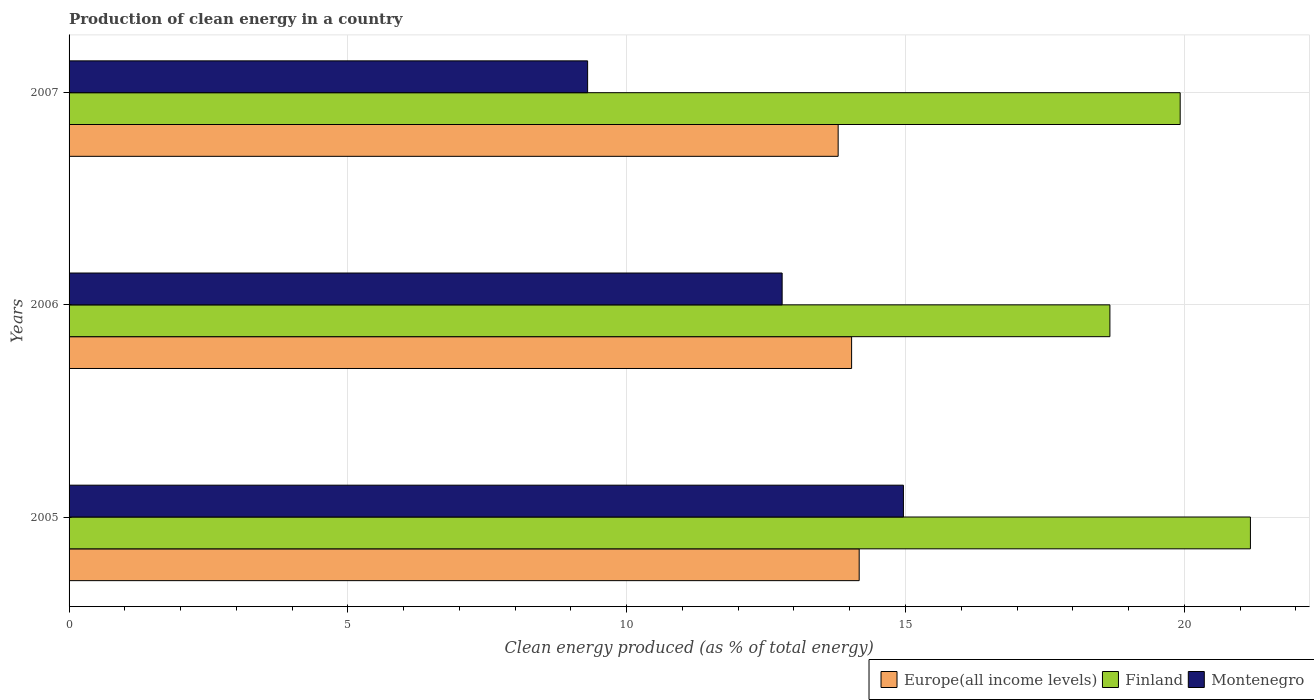How many groups of bars are there?
Offer a terse response. 3. How many bars are there on the 1st tick from the top?
Offer a very short reply. 3. What is the label of the 2nd group of bars from the top?
Your response must be concise. 2006. What is the percentage of clean energy produced in Montenegro in 2007?
Your answer should be very brief. 9.3. Across all years, what is the maximum percentage of clean energy produced in Montenegro?
Ensure brevity in your answer.  14.96. Across all years, what is the minimum percentage of clean energy produced in Montenegro?
Offer a very short reply. 9.3. In which year was the percentage of clean energy produced in Finland maximum?
Your response must be concise. 2005. What is the total percentage of clean energy produced in Montenegro in the graph?
Provide a succinct answer. 37.05. What is the difference between the percentage of clean energy produced in Europe(all income levels) in 2006 and that in 2007?
Offer a very short reply. 0.24. What is the difference between the percentage of clean energy produced in Montenegro in 2005 and the percentage of clean energy produced in Finland in 2007?
Offer a terse response. -4.96. What is the average percentage of clean energy produced in Europe(all income levels) per year?
Your response must be concise. 14. In the year 2006, what is the difference between the percentage of clean energy produced in Montenegro and percentage of clean energy produced in Europe(all income levels)?
Make the answer very short. -1.25. In how many years, is the percentage of clean energy produced in Finland greater than 6 %?
Keep it short and to the point. 3. What is the ratio of the percentage of clean energy produced in Europe(all income levels) in 2005 to that in 2007?
Provide a succinct answer. 1.03. Is the percentage of clean energy produced in Finland in 2005 less than that in 2006?
Provide a short and direct response. No. What is the difference between the highest and the second highest percentage of clean energy produced in Europe(all income levels)?
Make the answer very short. 0.14. What is the difference between the highest and the lowest percentage of clean energy produced in Finland?
Provide a succinct answer. 2.52. In how many years, is the percentage of clean energy produced in Finland greater than the average percentage of clean energy produced in Finland taken over all years?
Your response must be concise. 2. What does the 3rd bar from the top in 2007 represents?
Provide a short and direct response. Europe(all income levels). Is it the case that in every year, the sum of the percentage of clean energy produced in Europe(all income levels) and percentage of clean energy produced in Finland is greater than the percentage of clean energy produced in Montenegro?
Give a very brief answer. Yes. How many bars are there?
Your answer should be compact. 9. Are all the bars in the graph horizontal?
Offer a terse response. Yes. Are the values on the major ticks of X-axis written in scientific E-notation?
Your answer should be compact. No. Does the graph contain any zero values?
Give a very brief answer. No. Does the graph contain grids?
Offer a very short reply. Yes. What is the title of the graph?
Give a very brief answer. Production of clean energy in a country. What is the label or title of the X-axis?
Provide a succinct answer. Clean energy produced (as % of total energy). What is the label or title of the Y-axis?
Your answer should be compact. Years. What is the Clean energy produced (as % of total energy) of Europe(all income levels) in 2005?
Keep it short and to the point. 14.17. What is the Clean energy produced (as % of total energy) in Finland in 2005?
Your answer should be very brief. 21.19. What is the Clean energy produced (as % of total energy) in Montenegro in 2005?
Provide a succinct answer. 14.96. What is the Clean energy produced (as % of total energy) in Europe(all income levels) in 2006?
Your answer should be compact. 14.03. What is the Clean energy produced (as % of total energy) in Finland in 2006?
Ensure brevity in your answer.  18.67. What is the Clean energy produced (as % of total energy) of Montenegro in 2006?
Your answer should be very brief. 12.79. What is the Clean energy produced (as % of total energy) in Europe(all income levels) in 2007?
Offer a terse response. 13.79. What is the Clean energy produced (as % of total energy) of Finland in 2007?
Offer a very short reply. 19.93. What is the Clean energy produced (as % of total energy) of Montenegro in 2007?
Provide a short and direct response. 9.3. Across all years, what is the maximum Clean energy produced (as % of total energy) of Europe(all income levels)?
Provide a succinct answer. 14.17. Across all years, what is the maximum Clean energy produced (as % of total energy) in Finland?
Give a very brief answer. 21.19. Across all years, what is the maximum Clean energy produced (as % of total energy) of Montenegro?
Your response must be concise. 14.96. Across all years, what is the minimum Clean energy produced (as % of total energy) of Europe(all income levels)?
Your answer should be very brief. 13.79. Across all years, what is the minimum Clean energy produced (as % of total energy) of Finland?
Provide a succinct answer. 18.67. Across all years, what is the minimum Clean energy produced (as % of total energy) of Montenegro?
Offer a very short reply. 9.3. What is the total Clean energy produced (as % of total energy) of Europe(all income levels) in the graph?
Give a very brief answer. 42. What is the total Clean energy produced (as % of total energy) of Finland in the graph?
Provide a succinct answer. 59.78. What is the total Clean energy produced (as % of total energy) of Montenegro in the graph?
Make the answer very short. 37.05. What is the difference between the Clean energy produced (as % of total energy) of Europe(all income levels) in 2005 and that in 2006?
Provide a short and direct response. 0.14. What is the difference between the Clean energy produced (as % of total energy) in Finland in 2005 and that in 2006?
Your answer should be very brief. 2.52. What is the difference between the Clean energy produced (as % of total energy) of Montenegro in 2005 and that in 2006?
Offer a very short reply. 2.17. What is the difference between the Clean energy produced (as % of total energy) of Europe(all income levels) in 2005 and that in 2007?
Your answer should be very brief. 0.38. What is the difference between the Clean energy produced (as % of total energy) in Finland in 2005 and that in 2007?
Give a very brief answer. 1.26. What is the difference between the Clean energy produced (as % of total energy) in Montenegro in 2005 and that in 2007?
Your answer should be very brief. 5.66. What is the difference between the Clean energy produced (as % of total energy) of Europe(all income levels) in 2006 and that in 2007?
Offer a very short reply. 0.24. What is the difference between the Clean energy produced (as % of total energy) of Finland in 2006 and that in 2007?
Ensure brevity in your answer.  -1.26. What is the difference between the Clean energy produced (as % of total energy) of Montenegro in 2006 and that in 2007?
Your answer should be very brief. 3.49. What is the difference between the Clean energy produced (as % of total energy) of Europe(all income levels) in 2005 and the Clean energy produced (as % of total energy) of Finland in 2006?
Provide a short and direct response. -4.5. What is the difference between the Clean energy produced (as % of total energy) in Europe(all income levels) in 2005 and the Clean energy produced (as % of total energy) in Montenegro in 2006?
Offer a very short reply. 1.38. What is the difference between the Clean energy produced (as % of total energy) of Finland in 2005 and the Clean energy produced (as % of total energy) of Montenegro in 2006?
Provide a succinct answer. 8.4. What is the difference between the Clean energy produced (as % of total energy) of Europe(all income levels) in 2005 and the Clean energy produced (as % of total energy) of Finland in 2007?
Your response must be concise. -5.76. What is the difference between the Clean energy produced (as % of total energy) in Europe(all income levels) in 2005 and the Clean energy produced (as % of total energy) in Montenegro in 2007?
Offer a terse response. 4.87. What is the difference between the Clean energy produced (as % of total energy) of Finland in 2005 and the Clean energy produced (as % of total energy) of Montenegro in 2007?
Make the answer very short. 11.89. What is the difference between the Clean energy produced (as % of total energy) in Europe(all income levels) in 2006 and the Clean energy produced (as % of total energy) in Finland in 2007?
Offer a terse response. -5.89. What is the difference between the Clean energy produced (as % of total energy) in Europe(all income levels) in 2006 and the Clean energy produced (as % of total energy) in Montenegro in 2007?
Ensure brevity in your answer.  4.73. What is the difference between the Clean energy produced (as % of total energy) of Finland in 2006 and the Clean energy produced (as % of total energy) of Montenegro in 2007?
Give a very brief answer. 9.37. What is the average Clean energy produced (as % of total energy) in Europe(all income levels) per year?
Your response must be concise. 14. What is the average Clean energy produced (as % of total energy) of Finland per year?
Your answer should be compact. 19.93. What is the average Clean energy produced (as % of total energy) of Montenegro per year?
Make the answer very short. 12.35. In the year 2005, what is the difference between the Clean energy produced (as % of total energy) of Europe(all income levels) and Clean energy produced (as % of total energy) of Finland?
Your response must be concise. -7.02. In the year 2005, what is the difference between the Clean energy produced (as % of total energy) of Europe(all income levels) and Clean energy produced (as % of total energy) of Montenegro?
Make the answer very short. -0.79. In the year 2005, what is the difference between the Clean energy produced (as % of total energy) of Finland and Clean energy produced (as % of total energy) of Montenegro?
Your response must be concise. 6.22. In the year 2006, what is the difference between the Clean energy produced (as % of total energy) of Europe(all income levels) and Clean energy produced (as % of total energy) of Finland?
Give a very brief answer. -4.63. In the year 2006, what is the difference between the Clean energy produced (as % of total energy) in Europe(all income levels) and Clean energy produced (as % of total energy) in Montenegro?
Offer a very short reply. 1.25. In the year 2006, what is the difference between the Clean energy produced (as % of total energy) of Finland and Clean energy produced (as % of total energy) of Montenegro?
Your answer should be compact. 5.88. In the year 2007, what is the difference between the Clean energy produced (as % of total energy) in Europe(all income levels) and Clean energy produced (as % of total energy) in Finland?
Your answer should be compact. -6.13. In the year 2007, what is the difference between the Clean energy produced (as % of total energy) in Europe(all income levels) and Clean energy produced (as % of total energy) in Montenegro?
Ensure brevity in your answer.  4.49. In the year 2007, what is the difference between the Clean energy produced (as % of total energy) of Finland and Clean energy produced (as % of total energy) of Montenegro?
Provide a short and direct response. 10.63. What is the ratio of the Clean energy produced (as % of total energy) of Europe(all income levels) in 2005 to that in 2006?
Make the answer very short. 1.01. What is the ratio of the Clean energy produced (as % of total energy) in Finland in 2005 to that in 2006?
Your response must be concise. 1.14. What is the ratio of the Clean energy produced (as % of total energy) of Montenegro in 2005 to that in 2006?
Offer a very short reply. 1.17. What is the ratio of the Clean energy produced (as % of total energy) of Europe(all income levels) in 2005 to that in 2007?
Your answer should be compact. 1.03. What is the ratio of the Clean energy produced (as % of total energy) of Finland in 2005 to that in 2007?
Your answer should be very brief. 1.06. What is the ratio of the Clean energy produced (as % of total energy) of Montenegro in 2005 to that in 2007?
Make the answer very short. 1.61. What is the ratio of the Clean energy produced (as % of total energy) of Europe(all income levels) in 2006 to that in 2007?
Your answer should be compact. 1.02. What is the ratio of the Clean energy produced (as % of total energy) of Finland in 2006 to that in 2007?
Offer a very short reply. 0.94. What is the ratio of the Clean energy produced (as % of total energy) of Montenegro in 2006 to that in 2007?
Your response must be concise. 1.38. What is the difference between the highest and the second highest Clean energy produced (as % of total energy) of Europe(all income levels)?
Offer a very short reply. 0.14. What is the difference between the highest and the second highest Clean energy produced (as % of total energy) in Finland?
Your response must be concise. 1.26. What is the difference between the highest and the second highest Clean energy produced (as % of total energy) in Montenegro?
Provide a short and direct response. 2.17. What is the difference between the highest and the lowest Clean energy produced (as % of total energy) in Europe(all income levels)?
Your response must be concise. 0.38. What is the difference between the highest and the lowest Clean energy produced (as % of total energy) in Finland?
Provide a succinct answer. 2.52. What is the difference between the highest and the lowest Clean energy produced (as % of total energy) of Montenegro?
Your answer should be compact. 5.66. 